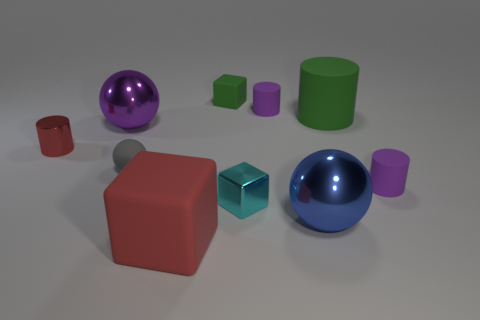Subtract all spheres. How many objects are left? 7 Add 1 tiny red matte objects. How many tiny red matte objects exist? 1 Subtract 0 brown cubes. How many objects are left? 10 Subtract all yellow rubber cubes. Subtract all gray balls. How many objects are left? 9 Add 4 big purple metal objects. How many big purple metal objects are left? 5 